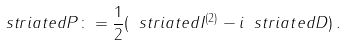<formula> <loc_0><loc_0><loc_500><loc_500>\ s t r i a t e d { P } \colon = \frac { 1 } { 2 } ( \ s t r i a t e d { I } ^ { ( 2 ) } - i \ s t r i a t e d { D } ) \, .</formula> 